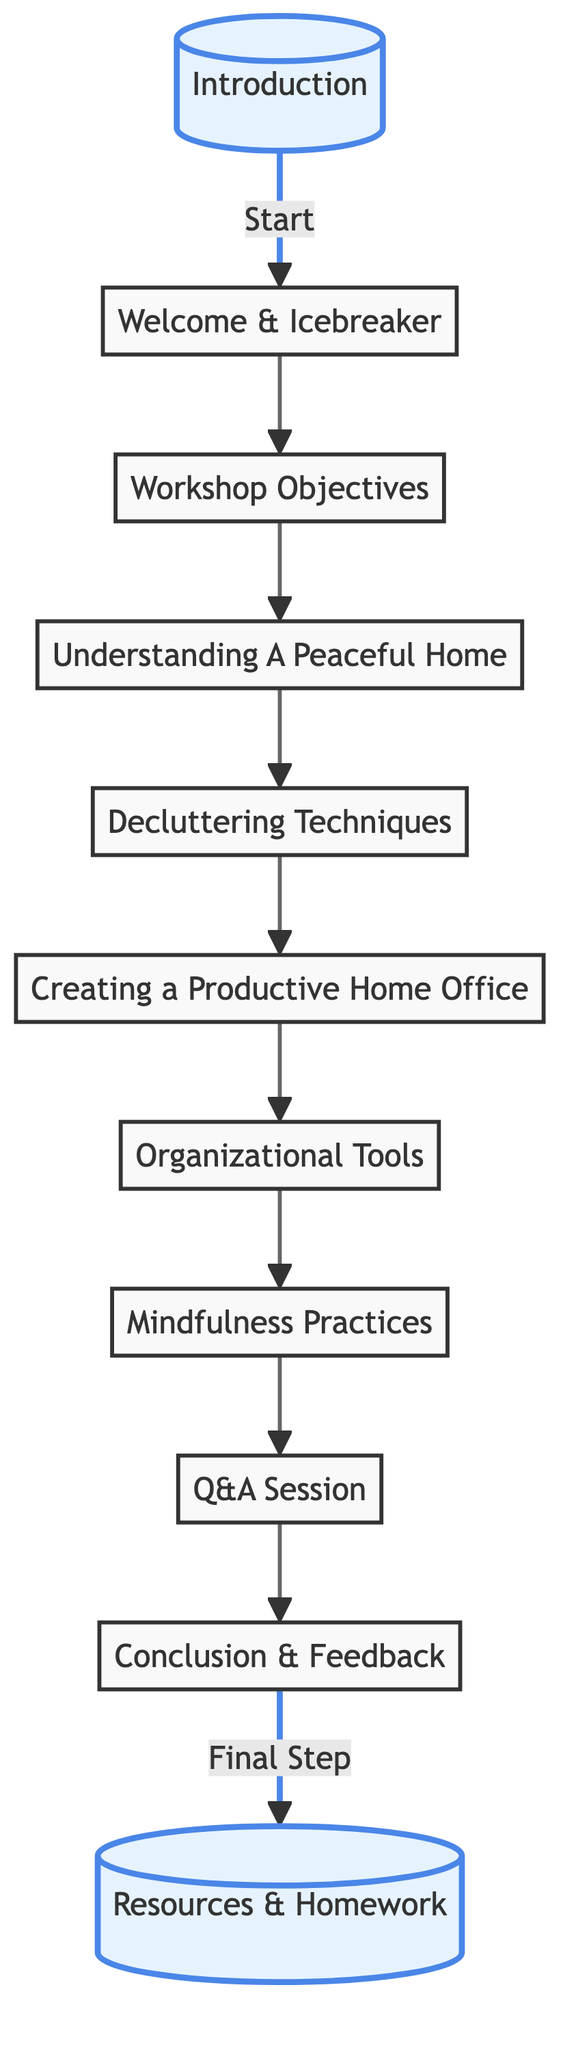What is the first node in the diagram? The first node is "Introduction," which is indicated at the start of the flowchart.
Answer: Introduction How many main topics are covered in the workshop structure? The main topics in the workshop structure are indicated by the nodes between "Workshop Objectives" and "Conclusion & Feedback," which total to eight nodes.
Answer: 8 What follows the “Q&A Session” in the diagram? The node that follows the "Q&A Session" is "Conclusion & Feedback," as indicated by the directional flow in the diagram.
Answer: Conclusion & Feedback Which node emphasizes the final step of the workshop? The node that indicates the final step of the workshop is "Resources & Homework," which is highlighted at the end of the flowchart.
Answer: Resources & Homework Which two nodes are linked by the label "Start"? The nodes linked by the label "Start" are "Introduction" and "Welcome & Icebreaker," indicating the beginning of the workshop structure.
Answer: Introduction and Welcome & Icebreaker What is the relationship between "Organizational Tools" and "Mindfulness Practices"? "Organizational Tools" leads directly to "Mindfulness Practices," showing a sequential relationship in the workshop flow.
Answer: Sequential How many connections flow out from the "Understanding A Peaceful Home" node? There is one connection flowing out from the "Understanding A Peaceful Home" node that leads to "Decluttering Techniques."
Answer: 1 Which node is highlighted in the diagram other than the "Introduction"? The other highlighted node in the diagram is "Resources & Homework," which signifies an important part of the workshop.
Answer: Resources & Homework What does the flow from "Decluttering Techniques" lead to? The flow from "Decluttering Techniques" leads to "Creating a Productive Home Office," indicating the progression of topics in the session.
Answer: Creating a Productive Home Office 